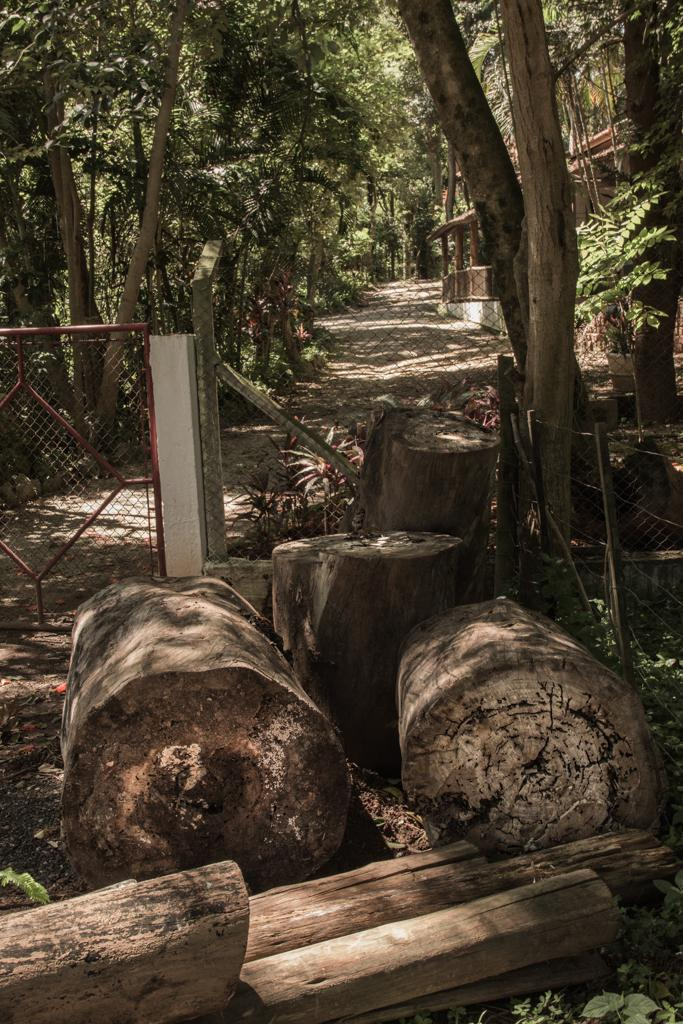What type of material is visible in the image? Wooden logs and a mesh are visible in the image. What type of natural elements can be seen in the image? Plants and trees are visible in the image. What is the ground like in the image? The ground is visible in the image. What architectural features are present in the image? Poles and a gate are present in the image. What can be seen in the background of the image? Trees, poles, a walkway, plants, and railings are visible in the background of the image. Where is the desk located in the image? There is no desk present in the image. How many sheep can be seen grazing in the background of the image? There are no sheep present in the image. 